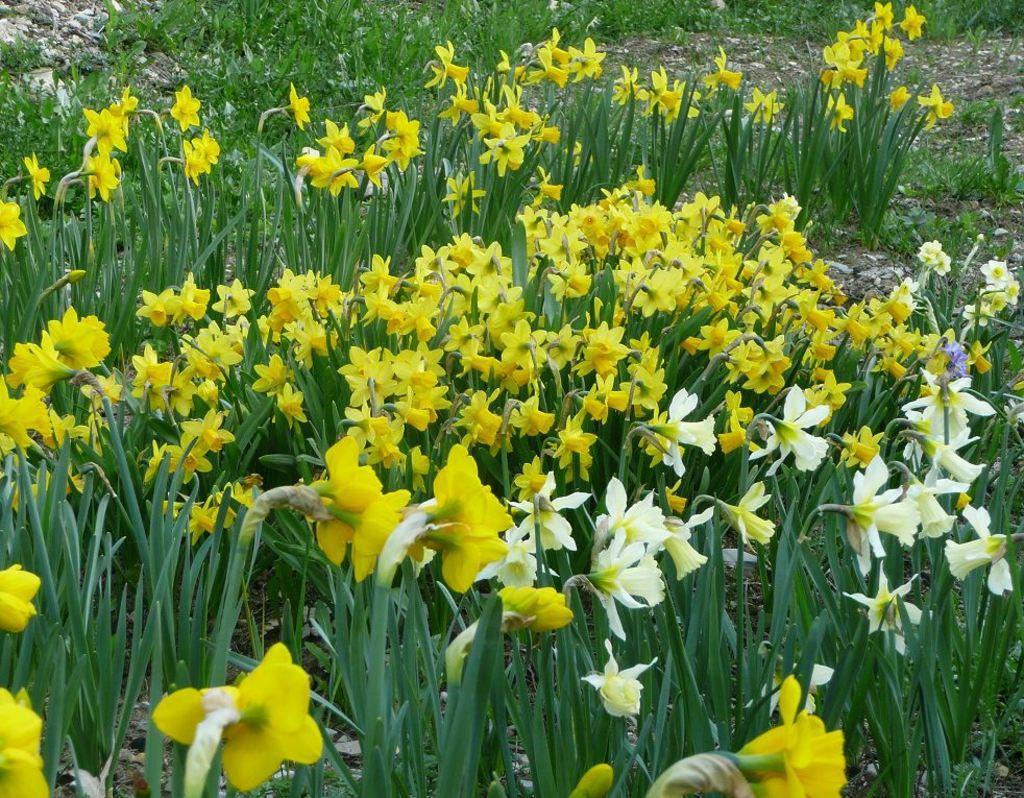How would you summarize this image in a sentence or two? In this image I can see few plants which are green in color and to them I can see few flowers which are yellow and cream in color. In the background I can see some grass on the ground. 